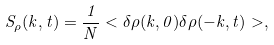<formula> <loc_0><loc_0><loc_500><loc_500>S _ { \rho } ( k , t ) = \frac { 1 } { N } < \delta \rho ( k , 0 ) \delta \rho ( - k , t ) > ,</formula> 